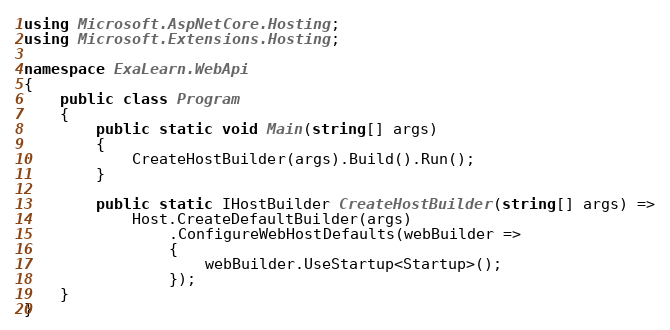<code> <loc_0><loc_0><loc_500><loc_500><_C#_>using Microsoft.AspNetCore.Hosting;
using Microsoft.Extensions.Hosting;

namespace ExaLearn.WebApi
{
    public class Program
    {
        public static void Main(string[] args)
        {
            CreateHostBuilder(args).Build().Run();
        }

        public static IHostBuilder CreateHostBuilder(string[] args) =>
            Host.CreateDefaultBuilder(args)
                .ConfigureWebHostDefaults(webBuilder =>
                {
                    webBuilder.UseStartup<Startup>();
                });
    }
}
</code> 